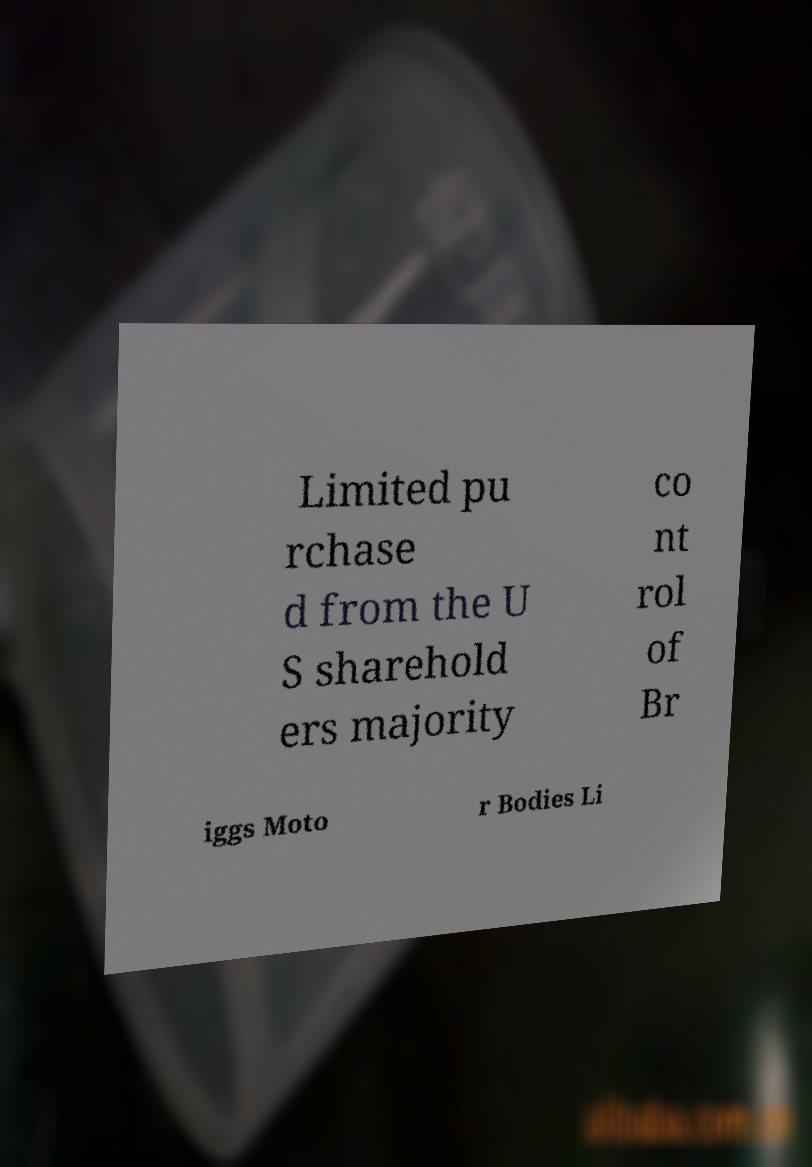Could you extract and type out the text from this image? Limited pu rchase d from the U S sharehold ers majority co nt rol of Br iggs Moto r Bodies Li 